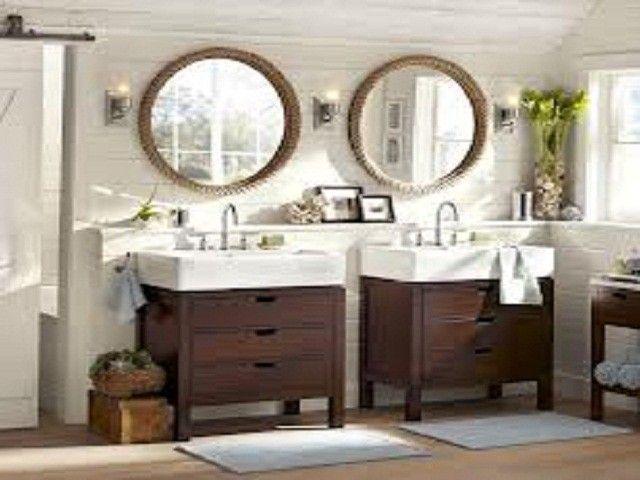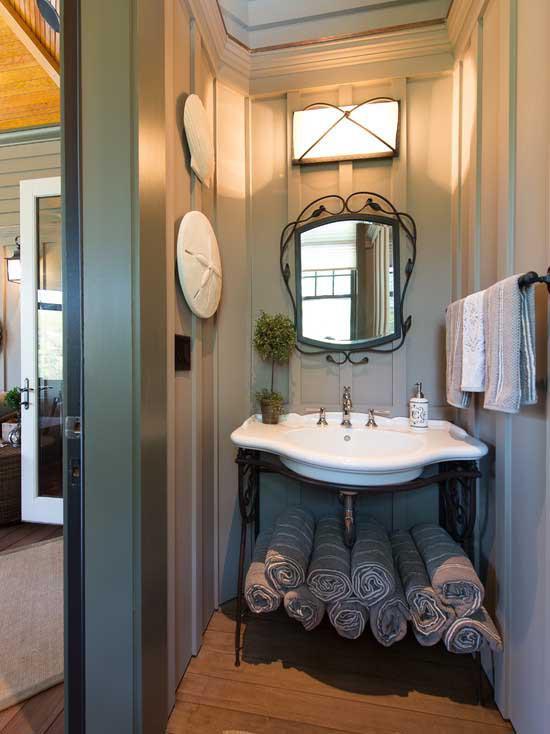The first image is the image on the left, the second image is the image on the right. Given the left and right images, does the statement "All of the bathrooms have double sinks." hold true? Answer yes or no. No. The first image is the image on the left, the second image is the image on the right. For the images shown, is this caption "a toilet can be seen" true? Answer yes or no. No. 